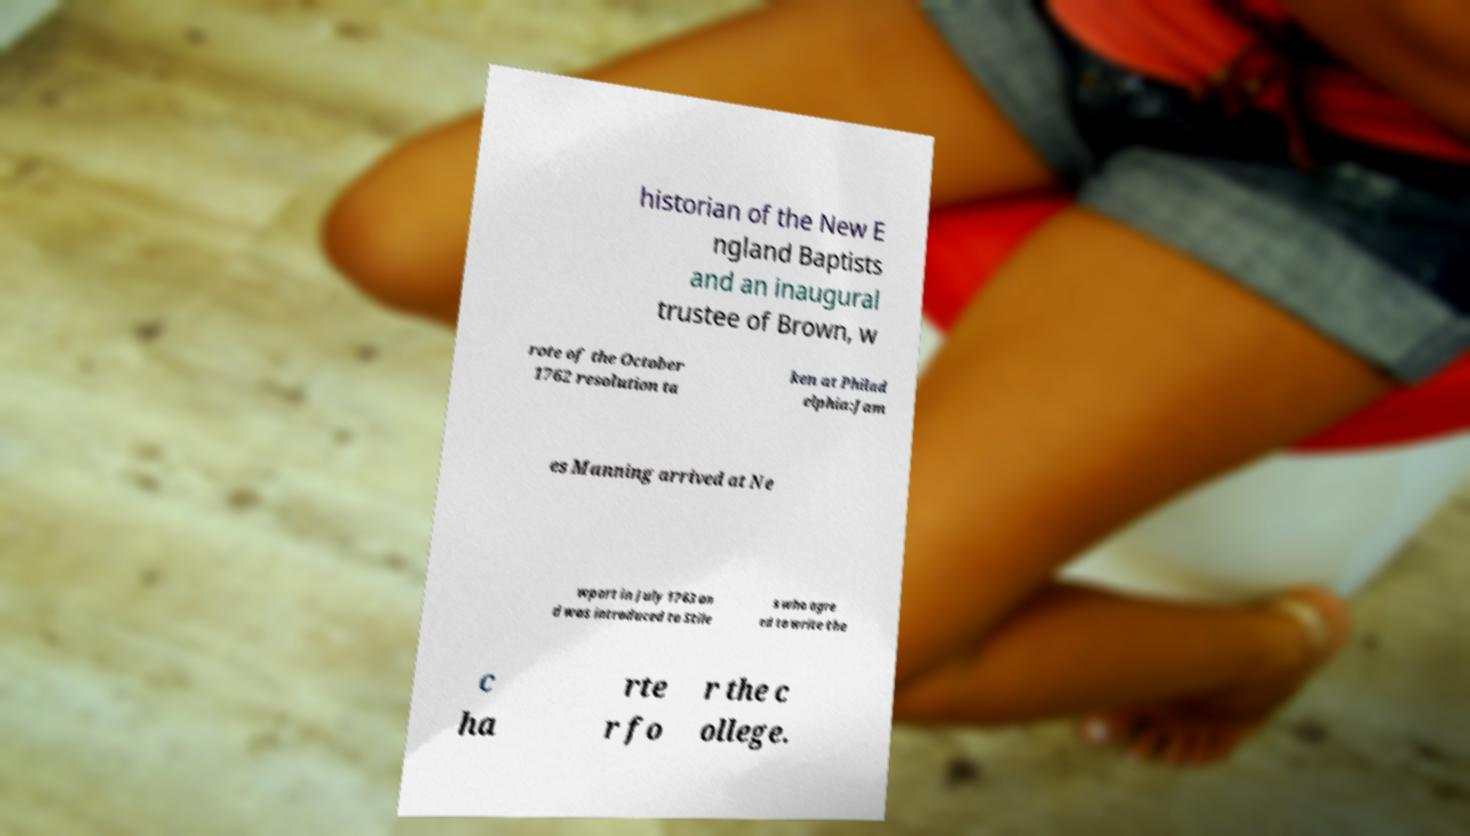There's text embedded in this image that I need extracted. Can you transcribe it verbatim? historian of the New E ngland Baptists and an inaugural trustee of Brown, w rote of the October 1762 resolution ta ken at Philad elphia:Jam es Manning arrived at Ne wport in July 1763 an d was introduced to Stile s who agre ed to write the c ha rte r fo r the c ollege. 